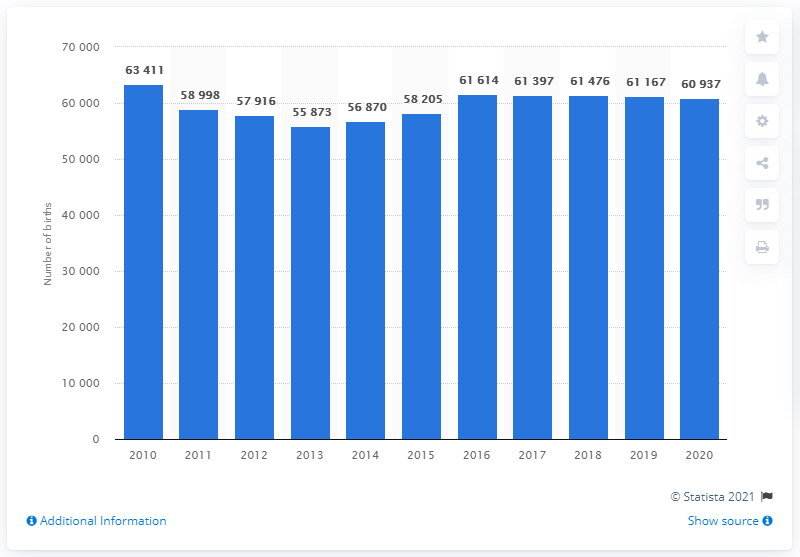Draw attention to some important aspects in this diagram. As of 2020, a total of 60,937 live births were registered in Denmark. The number of live births in Denmark increased in 2013. 